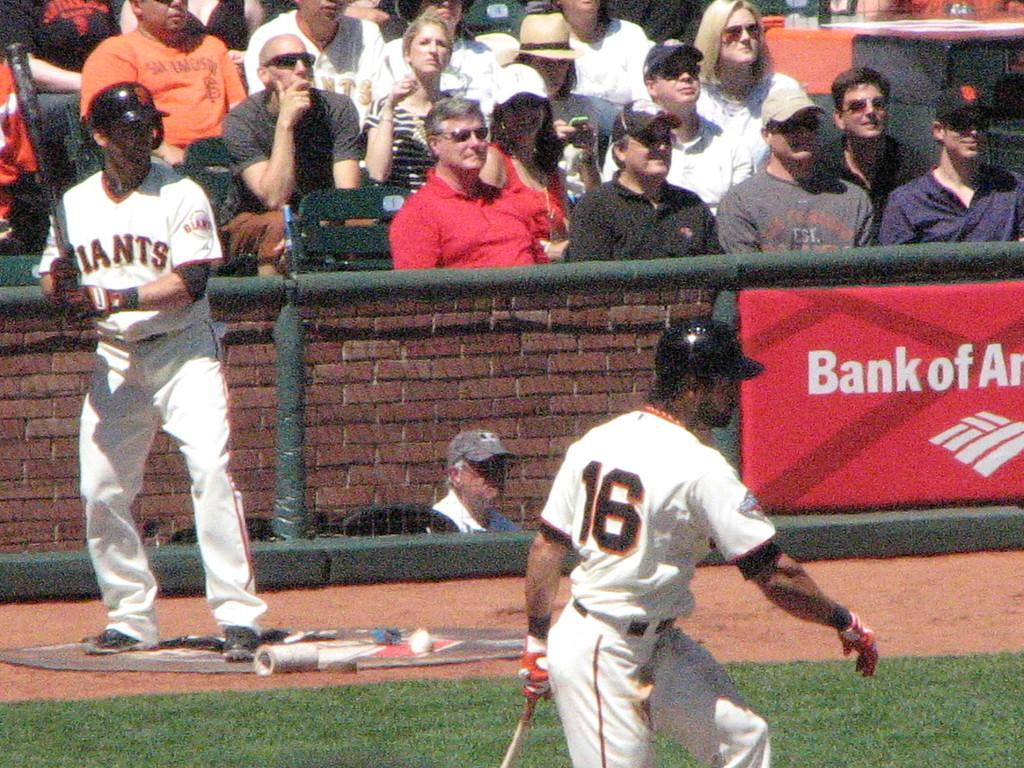<image>
Give a short and clear explanation of the subsequent image. A baseball player is wearing number 16 on his jersey. 